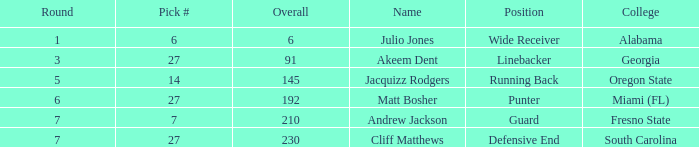Which overall's pick number was 14? 145.0. 